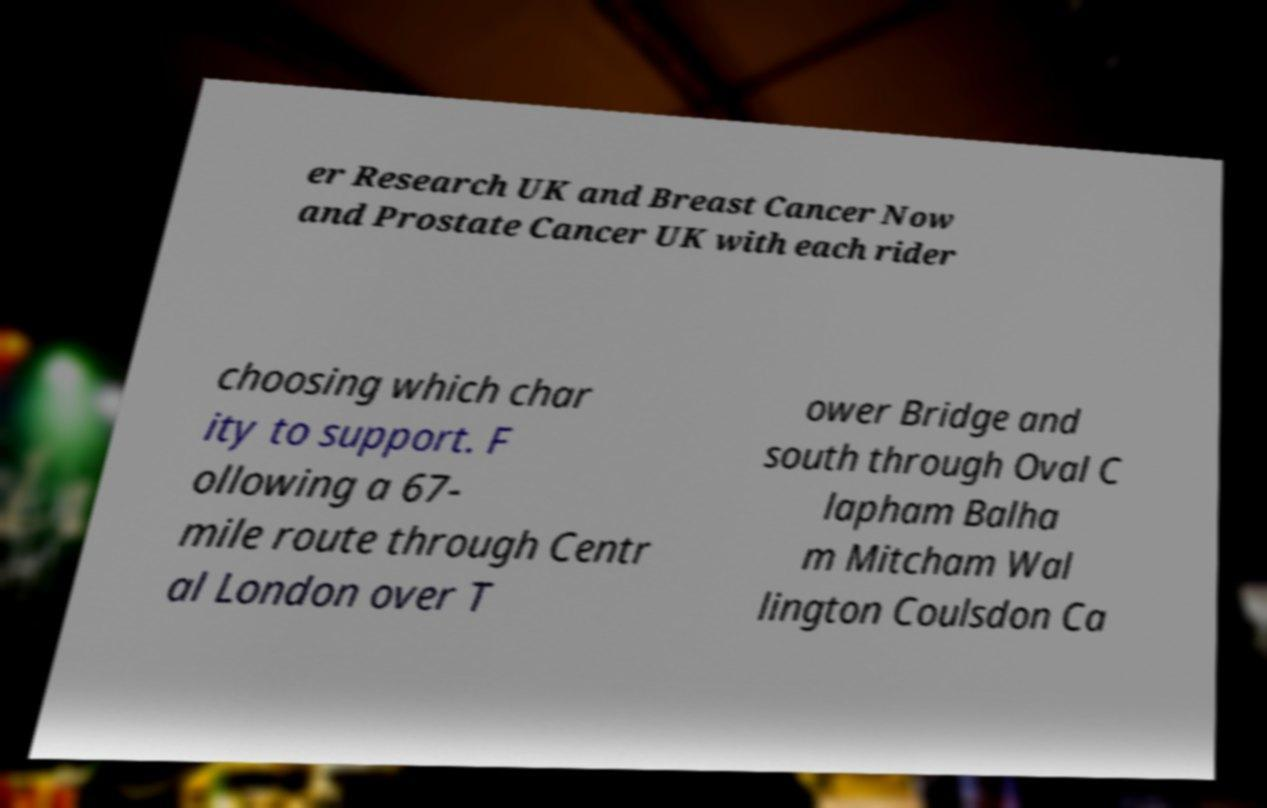There's text embedded in this image that I need extracted. Can you transcribe it verbatim? er Research UK and Breast Cancer Now and Prostate Cancer UK with each rider choosing which char ity to support. F ollowing a 67- mile route through Centr al London over T ower Bridge and south through Oval C lapham Balha m Mitcham Wal lington Coulsdon Ca 